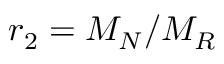Convert formula to latex. <formula><loc_0><loc_0><loc_500><loc_500>r _ { 2 } = M _ { N } / M _ { R }</formula> 